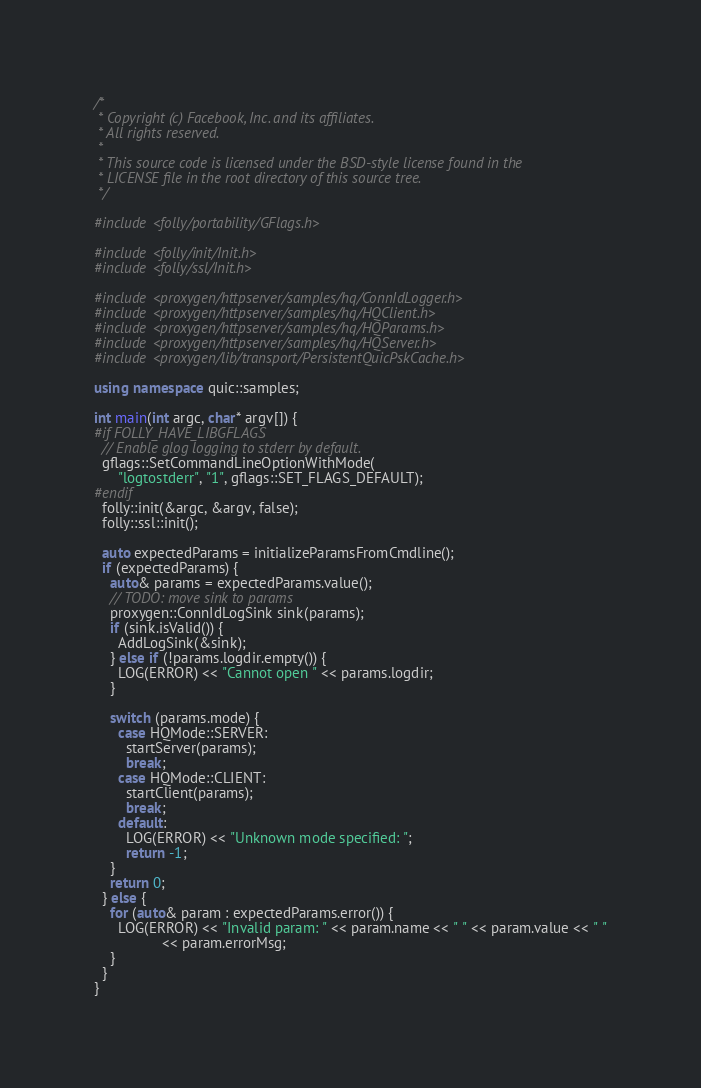<code> <loc_0><loc_0><loc_500><loc_500><_C++_>/*
 * Copyright (c) Facebook, Inc. and its affiliates.
 * All rights reserved.
 *
 * This source code is licensed under the BSD-style license found in the
 * LICENSE file in the root directory of this source tree.
 */

#include <folly/portability/GFlags.h>

#include <folly/init/Init.h>
#include <folly/ssl/Init.h>

#include <proxygen/httpserver/samples/hq/ConnIdLogger.h>
#include <proxygen/httpserver/samples/hq/HQClient.h>
#include <proxygen/httpserver/samples/hq/HQParams.h>
#include <proxygen/httpserver/samples/hq/HQServer.h>
#include <proxygen/lib/transport/PersistentQuicPskCache.h>

using namespace quic::samples;

int main(int argc, char* argv[]) {
#if FOLLY_HAVE_LIBGFLAGS
  // Enable glog logging to stderr by default.
  gflags::SetCommandLineOptionWithMode(
      "logtostderr", "1", gflags::SET_FLAGS_DEFAULT);
#endif
  folly::init(&argc, &argv, false);
  folly::ssl::init();

  auto expectedParams = initializeParamsFromCmdline();
  if (expectedParams) {
    auto& params = expectedParams.value();
    // TODO: move sink to params
    proxygen::ConnIdLogSink sink(params);
    if (sink.isValid()) {
      AddLogSink(&sink);
    } else if (!params.logdir.empty()) {
      LOG(ERROR) << "Cannot open " << params.logdir;
    }

    switch (params.mode) {
      case HQMode::SERVER:
        startServer(params);
        break;
      case HQMode::CLIENT:
        startClient(params);
        break;
      default:
        LOG(ERROR) << "Unknown mode specified: ";
        return -1;
    }
    return 0;
  } else {
    for (auto& param : expectedParams.error()) {
      LOG(ERROR) << "Invalid param: " << param.name << " " << param.value << " "
                 << param.errorMsg;
    }
  }
}
</code> 